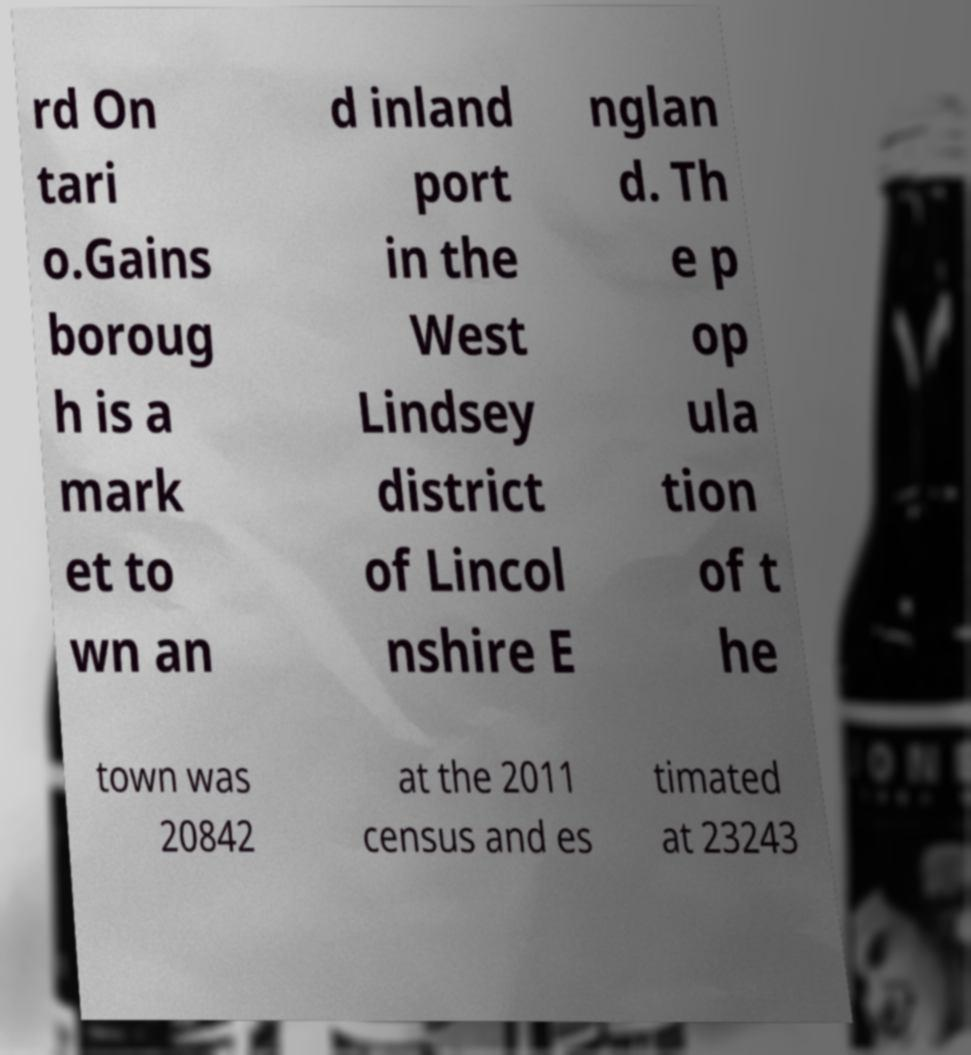Can you accurately transcribe the text from the provided image for me? rd On tari o.Gains boroug h is a mark et to wn an d inland port in the West Lindsey district of Lincol nshire E nglan d. Th e p op ula tion of t he town was 20842 at the 2011 census and es timated at 23243 